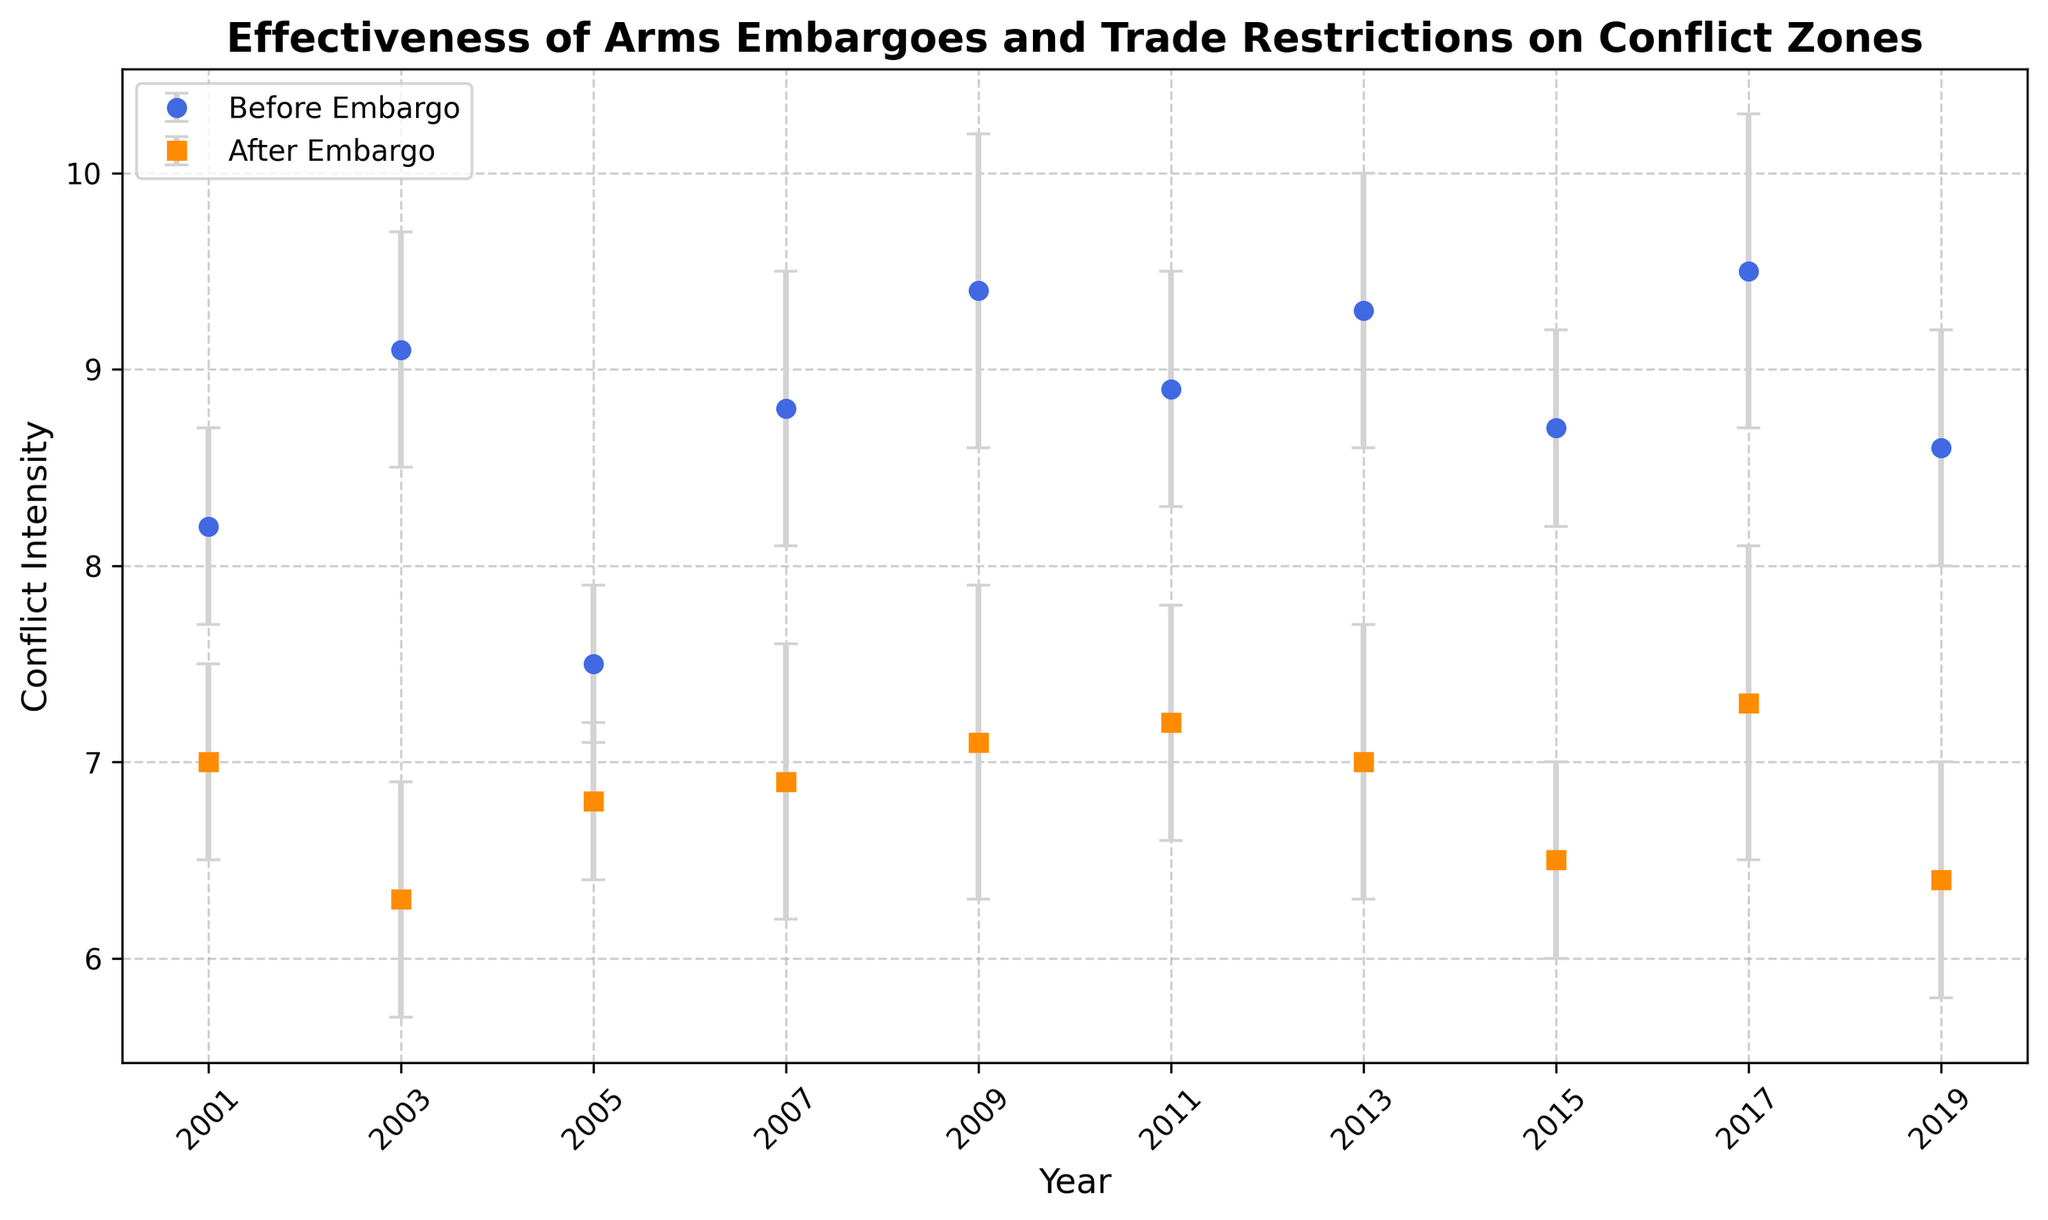Which country had the highest conflict intensity before the embargo in 2017? Looking at the figure, "Yemen" in 2017 had the highest conflict intensity before the embargo with a value of 9.5.
Answer: Yemen What is the average conflict intensity before the embargoes across all countries? Add the conflict intensity before the embargo values for all countries: 8.2 + 9.1 + 7.5 + 8.8 + 9.4 + 8.9 + 9.3 + 8.7 + 9.5 + 8.6 = 87. Then, divide by the number of countries, which is 10. So, the average is 87 / 10 = 8.7.
Answer: 8.7 Which country shows the greatest reduction in conflict intensity after the embargo? Calculate the difference between the conflict intensity before and after the embargo for each country and find the maximum. Liberia has the greatest reduction (9.1 - 6.3 = 2.8).
Answer: Liberia What is the difference in conflict intensity before and after the embargo for Congo? Subtract the conflict intensity after the embargo from before the embargo for Congo: 8.8 - 6.9 = 1.9.
Answer: 1.9 Which years have the same intensity after the embargo? Comparing the "Conflict_Intensity_After" values visually on the chart, both 2001 (Syria) and 2013 (Central African Republic) have the same conflict intensity of 7.0 after the embargo.
Answer: 2001 and 2013 How does the conflict intensity of Sudan in 2019 compare to Syria in 2001 before the embargo? Comparing the data points before the embargo, Sudan (8.6) in 2019 had a slightly higher conflict intensity than Syria (8.2) in 2001.
Answer: Sudan is higher What is the range of conflict intensity after the embargo across all countries? Determine the maximum and minimum conflict intensities after the embargo. The maximum is for Yemen in 2017 (7.3), and the minimum is for Liberia in 2003 (6.3). The range is 7.3 - 6.3 = 1.0.
Answer: 1.0 In which year did Iran's conflict intensity increase after the embargo? Compare Iran's conflict intensities before (7.5) and after (6.8) the embargo. Since it decreased, Iran's conflict intensity did not increase after the embargo in any year.
Answer: It did not increase What is the average error bar value across all years? Sum the error bars: 0.5 + 0.6 + 0.4 + 0.7 + 0.8 + 0.6 + 0.7 + 0.5 + 0.8 + 0.6 = 6.2. Then, divide by the number of years, which is 10. So, the average is 6.2 / 10 = 0.62.
Answer: 0.62 What is the median conflict intensity after the embargo? List conflict intensities after the embargo in ascending order: 6.3, 6.4, 6.5, 6.8, 6.9, 7.0, 7.0, 7.1, 7.2, 7.3. Since there are 10 data points, the median is the average of the 5th and 6th values: (6.9 + 7.0) / 2 = 6.95.
Answer: 6.95 